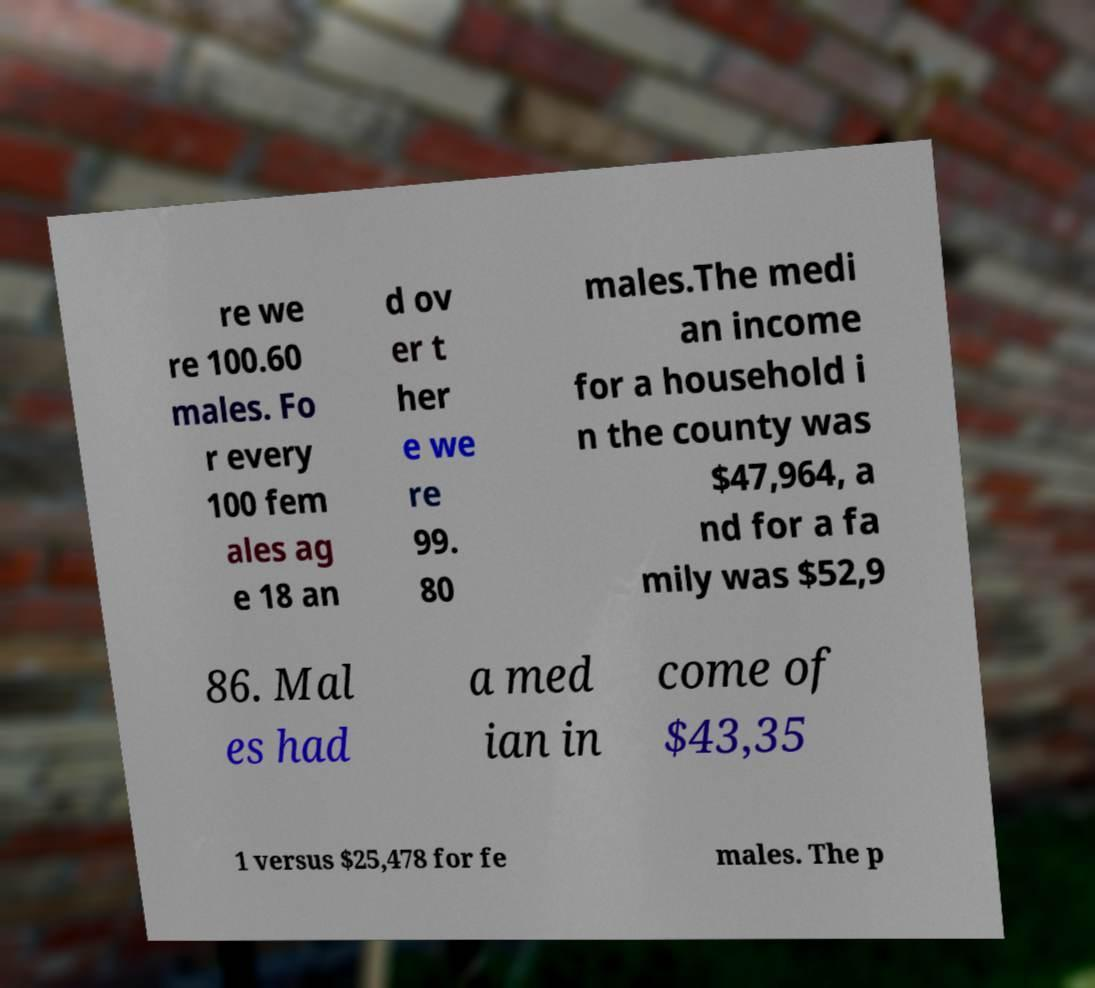Please read and relay the text visible in this image. What does it say? re we re 100.60 males. Fo r every 100 fem ales ag e 18 an d ov er t her e we re 99. 80 males.The medi an income for a household i n the county was $47,964, a nd for a fa mily was $52,9 86. Mal es had a med ian in come of $43,35 1 versus $25,478 for fe males. The p 